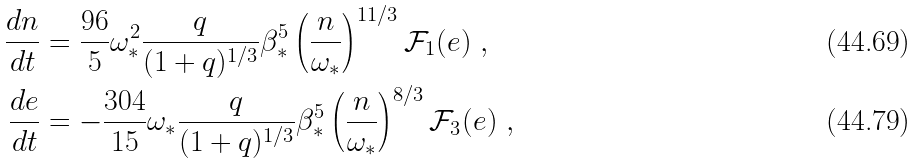<formula> <loc_0><loc_0><loc_500><loc_500>\frac { d n } { d t } & = \frac { 9 6 } { 5 } \omega _ { \ast } ^ { 2 } \frac { q } { ( 1 + q ) ^ { 1 / 3 } } \beta _ { \ast } ^ { 5 } \left ( \frac { n } { \omega _ { \ast } } \right ) ^ { 1 1 / 3 } \mathcal { F } _ { 1 } ( e ) \ , \\ \frac { d e } { d t } & = - \frac { 3 0 4 } { 1 5 } \omega _ { \ast } \frac { q } { ( 1 + q ) ^ { 1 / 3 } } \beta _ { \ast } ^ { 5 } \left ( \frac { n } { \omega _ { \ast } } \right ) ^ { 8 / 3 } \mathcal { F } _ { 3 } ( e ) \ ,</formula> 